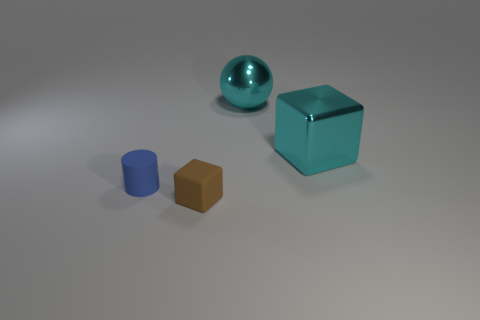There is a big ball that is the same material as the big cyan cube; what color is it? cyan 